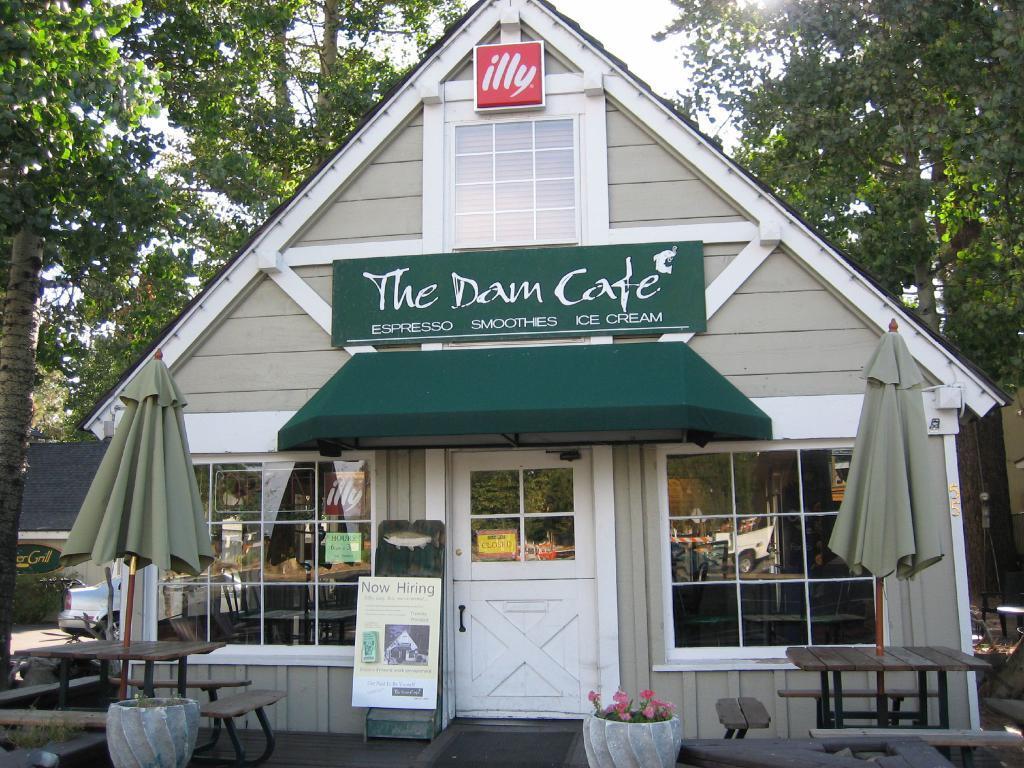In one or two sentences, can you explain what this image depicts? In the center of the image there is a shed and we can see parasols. At the bottom there are benches and flower pots. In the background there are trees and sky. We can see a board. 